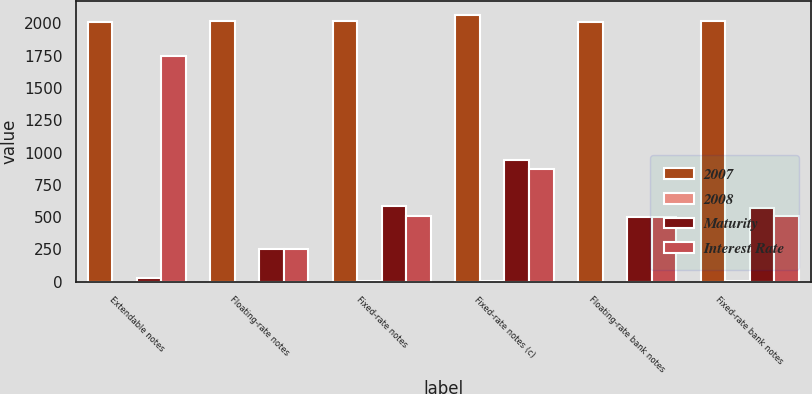Convert chart to OTSL. <chart><loc_0><loc_0><loc_500><loc_500><stacked_bar_chart><ecel><fcel>Extendable notes<fcel>Floating-rate notes<fcel>Fixed-rate notes<fcel>Fixed-rate notes (c)<fcel>Floating-rate bank notes<fcel>Fixed-rate bank notes<nl><fcel>2007<fcel>2009<fcel>2016<fcel>2017<fcel>2067<fcel>2013<fcel>2015<nl><fcel>2008<fcel>0.49<fcel>1.95<fcel>5.45<fcel>7.25<fcel>2.26<fcel>4.75<nl><fcel>Maturity<fcel>31<fcel>250<fcel>588<fcel>942<fcel>500<fcel>573<nl><fcel>Interest Rate<fcel>1745<fcel>250<fcel>510<fcel>876<fcel>500<fcel>513<nl></chart> 